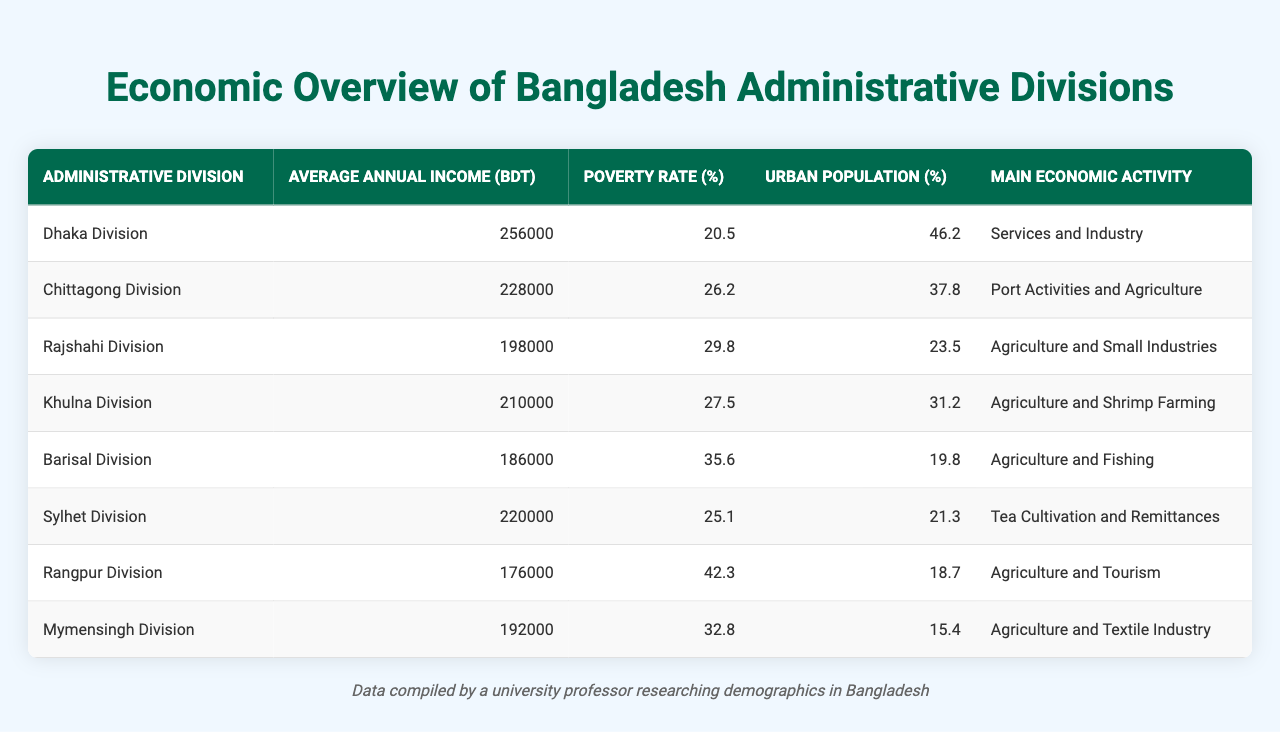Which division has the highest average annual income? By comparing the "Average Annual Income (BDT)" column, Dhaka Division has the highest value at 256,000 BDT.
Answer: Dhaka Division What is the poverty rate of Rajshahi Division? The "Poverty Rate (%)" for Rajshahi Division is found directly in the table, which shows the rate as 29.8%.
Answer: 29.8% How much higher is the average annual income in Dhaka Division compared to Rangpur Division? To find the difference, subtract Rangpur Division's income (176,000 BDT) from Dhaka Division's income (256,000 BDT): 256,000 - 176,000 = 80,000 BDT.
Answer: 80,000 BDT Is the urban population percentage in Khulna Division greater than in Barisal Division? The urban population percentages are 31.2% for Khulna Division and 19.8% for Barisal Division. Since 31.2% is greater than 19.8%, the answer is yes.
Answer: Yes What is the average poverty rate across all divisions? To calculate the average, sum up all poverty rates (20.5 + 26.2 + 29.8 + 27.5 + 35.6 + 25.1 + 42.3 + 32.8 =  2. 4). Then divide by the number of divisions (8):  2. 4/8 = 29.95%.
Answer: 29.95% Which division has the lowest poverty rate? Looking at the "Poverty Rate (%)" column, Rangpur Division has the lowest rate at 42.3%.
Answer: Rangpur Division How does the urban population percentage of Sylhet Division compare to that of Mymensingh Division? Sylhet Division has an urban population of 21.3% and Mymensingh Division has 15.4%. Since 21.3% is greater than 15.4%, it is concluded that Sylhet has a higher urban population percentage.
Answer: Sylhet Division What is the main economic activity of the Dhaka Division? The main economic activity listed for Dhaka Division in the table is "Services and Industry".
Answer: Services and Industry Which division's poverty rate is closest to the average poverty rate of 29.95%? Comparing each division’s poverty rates to the average, Mymensingh Division has a poverty rate of 32.8%, which is closest to the average of 29.95%.
Answer: Mymensingh Division Which division has both a higher average annual income and a lower poverty rate than the national average of 30%? Dhaka Division qualifies as it has an average annual income of 256,000 BDT and a poverty rate of 20.5%, both higher than the averages.
Answer: Dhaka Division 